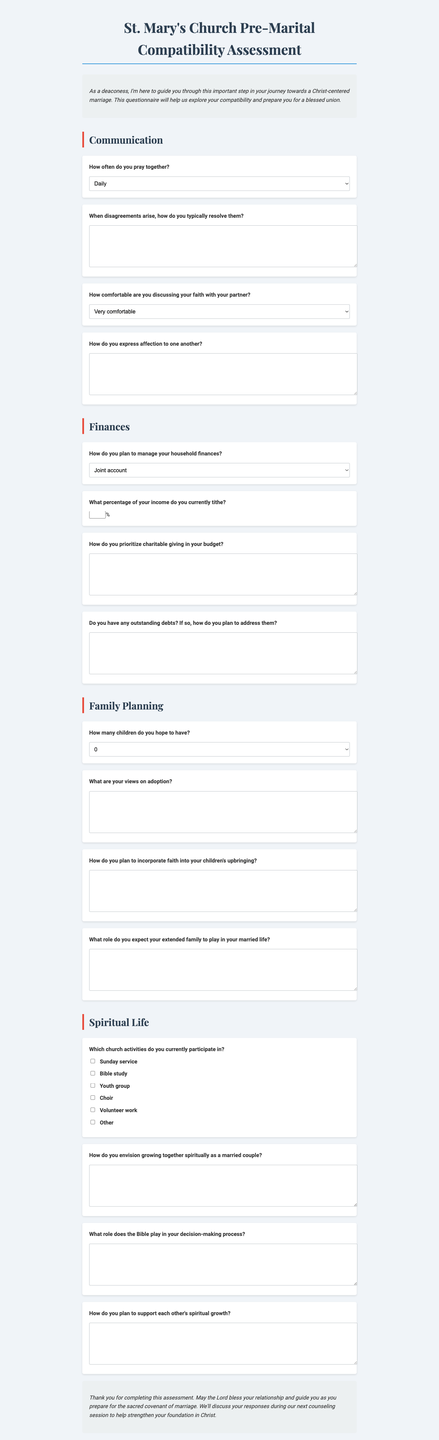What is the title of the form? The title is listed at the top of the document as the main heading.
Answer: St. Mary's Church Pre-Marital Compatibility Assessment How many sections are there in the document? The sections are clearly listed, and you can count them based on their headings.
Answer: Four What is the main focus of the questionnaire? The introduction clearly states the purpose of the questionnaire.
Answer: Compatibility assessment What type of question appears most frequently in the Communication section? You can check the questions listed under the Communication section to find the predominant type.
Answer: Open-ended What is one method of managing household finances mentioned in the Finances section? The options provided in the Finances section include different approaches to money management.
Answer: Joint account How do you plan to address debts? This is a typical question from the Finances section that prompts reflection on financial planning.
Answer: Open-ended How many children do you hope to have according to the Family Planning section? The Family Planning section includes a specific question regarding the number of children desired.
Answer: 1-2 What role does the Bible play in decision-making? This is a question from the Spiritual Life section that invites personal reflection.
Answer: Open-ended What activities are mentioned in the Spiritual Life section? You can find these listed as options in the questionnaire about church participation.
Answer: Sunday service, Bible study, Youth group, Choir, Volunteer work, Other 